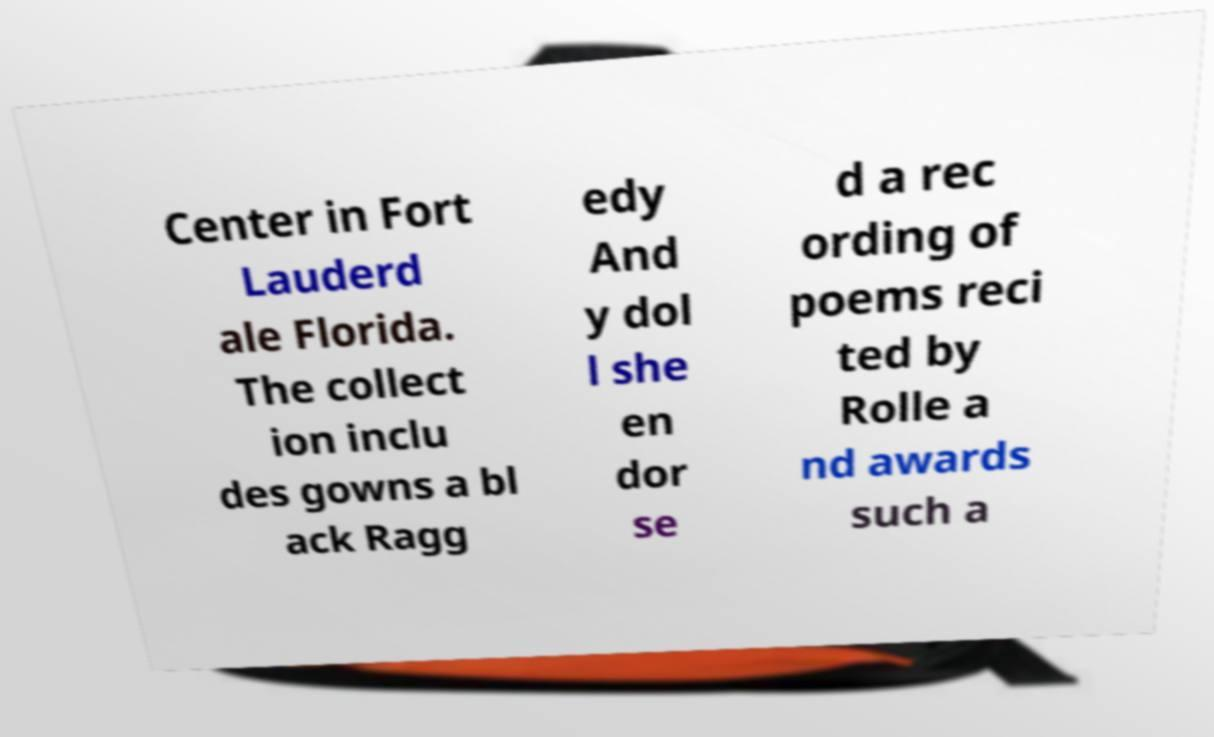What messages or text are displayed in this image? I need them in a readable, typed format. Center in Fort Lauderd ale Florida. The collect ion inclu des gowns a bl ack Ragg edy And y dol l she en dor se d a rec ording of poems reci ted by Rolle a nd awards such a 